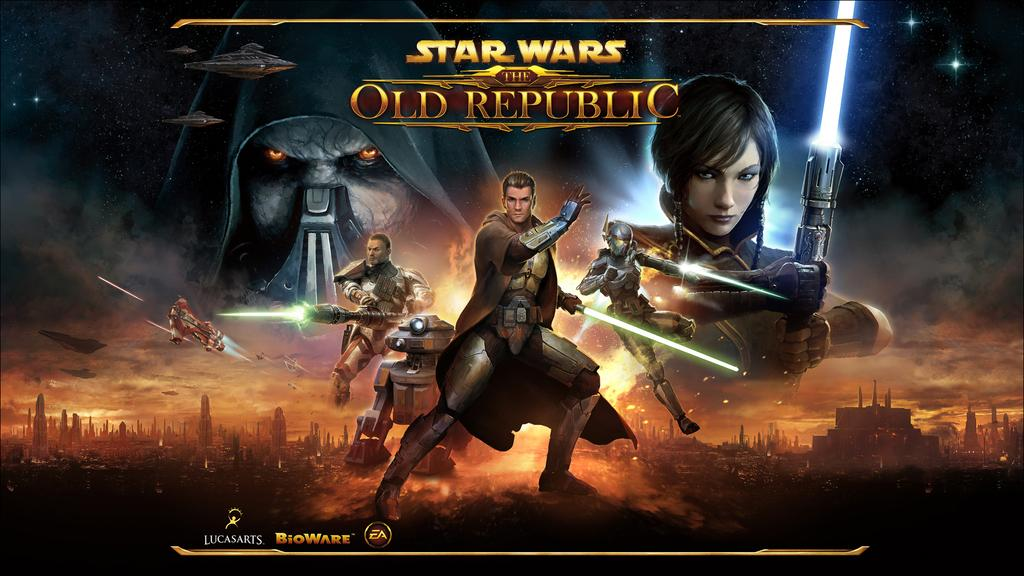<image>
Present a compact description of the photo's key features. A loading page for a video game called star wars the old republic. 